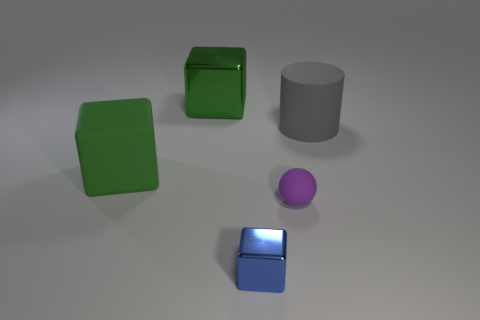Does the rubber cube have the same color as the large metal thing?
Provide a short and direct response. Yes. Is the tiny blue thing made of the same material as the green cube that is in front of the cylinder?
Give a very brief answer. No. How many blue objects have the same material as the tiny purple sphere?
Provide a succinct answer. 0. What color is the large cube that is made of the same material as the small blue block?
Provide a short and direct response. Green. There is a large gray matte thing; what shape is it?
Your answer should be very brief. Cylinder. What number of other large matte blocks are the same color as the big rubber block?
Your answer should be compact. 0. What shape is the matte object that is the same size as the green matte block?
Provide a succinct answer. Cylinder. Are there any blue objects that have the same size as the matte sphere?
Your answer should be very brief. Yes. What is the material of the sphere that is the same size as the blue block?
Ensure brevity in your answer.  Rubber. There is a metal block in front of the rubber object right of the tiny purple object; what size is it?
Keep it short and to the point. Small. 